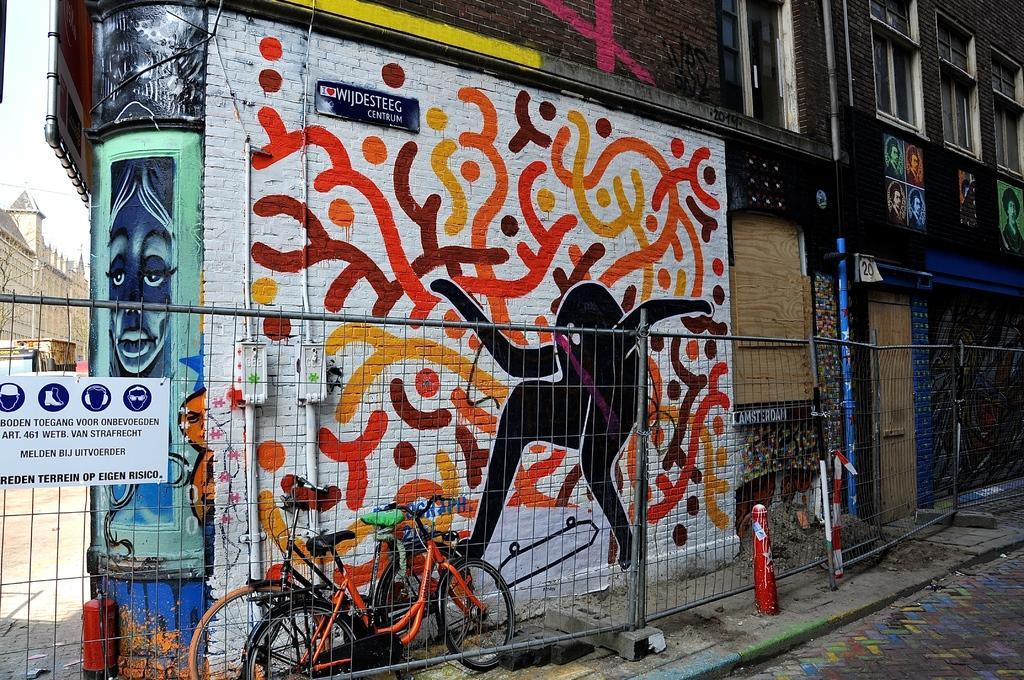Could you give a brief overview of what you see in this image? In this image in front there is a road. Beside the road there is a metal fence. In the background of the image there are cycles, buildings and sky. 